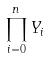<formula> <loc_0><loc_0><loc_500><loc_500>\prod _ { i = 0 } ^ { n } Y _ { i }</formula> 